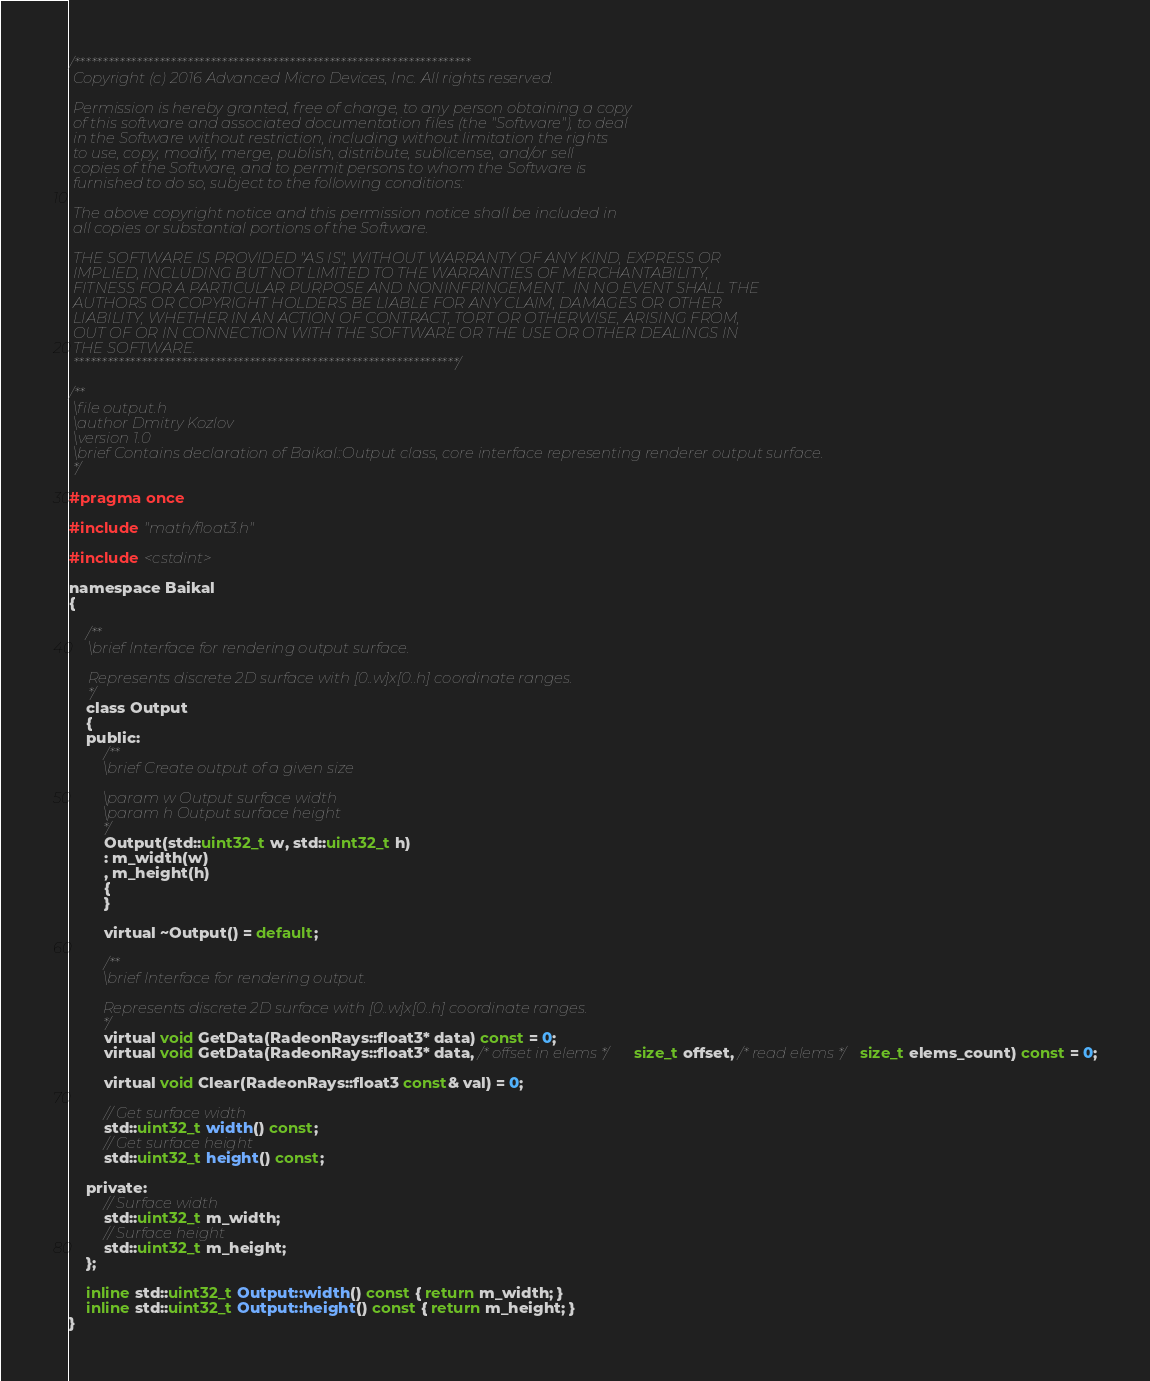<code> <loc_0><loc_0><loc_500><loc_500><_C_>/**********************************************************************
 Copyright (c) 2016 Advanced Micro Devices, Inc. All rights reserved.
 
 Permission is hereby granted, free of charge, to any person obtaining a copy
 of this software and associated documentation files (the "Software"), to deal
 in the Software without restriction, including without limitation the rights
 to use, copy, modify, merge, publish, distribute, sublicense, and/or sell
 copies of the Software, and to permit persons to whom the Software is
 furnished to do so, subject to the following conditions:
 
 The above copyright notice and this permission notice shall be included in
 all copies or substantial portions of the Software.
 
 THE SOFTWARE IS PROVIDED "AS IS", WITHOUT WARRANTY OF ANY KIND, EXPRESS OR
 IMPLIED, INCLUDING BUT NOT LIMITED TO THE WARRANTIES OF MERCHANTABILITY,
 FITNESS FOR A PARTICULAR PURPOSE AND NONINFRINGEMENT.  IN NO EVENT SHALL THE
 AUTHORS OR COPYRIGHT HOLDERS BE LIABLE FOR ANY CLAIM, DAMAGES OR OTHER
 LIABILITY, WHETHER IN AN ACTION OF CONTRACT, TORT OR OTHERWISE, ARISING FROM,
 OUT OF OR IN CONNECTION WITH THE SOFTWARE OR THE USE OR OTHER DEALINGS IN
 THE SOFTWARE.
 ********************************************************************/

/**
 \file output.h
 \author Dmitry Kozlov
 \version 1.0
 \brief Contains declaration of Baikal::Output class, core interface representing renderer output surface.
 */

#pragma once

#include "math/float3.h"

#include <cstdint>

namespace Baikal
{
    
    /**
     \brief Interface for rendering output surface.
     
     Represents discrete 2D surface with [0..w]x[0..h] coordinate ranges.
     */
    class Output
    {
    public:
        /**
         \brief Create output of a given size
         
         \param w Output surface width
         \param h Output surface height
         */
        Output(std::uint32_t w, std::uint32_t h)
        : m_width(w)
        , m_height(h)
        {
        }

        virtual ~Output() = default;

        /**
         \brief Interface for rendering output.
         
         Represents discrete 2D surface with [0..w]x[0..h] coordinate ranges.
         */
        virtual void GetData(RadeonRays::float3* data) const = 0;
        virtual void GetData(RadeonRays::float3* data, /* offset in elems */ size_t offset, /* read elems */size_t elems_count) const = 0;

        virtual void Clear(RadeonRays::float3 const& val) = 0;

        // Get surface width
        std::uint32_t width() const;
        // Get surface height
        std::uint32_t height() const;

    private:
        // Surface width
        std::uint32_t m_width;
        // Surface height
        std::uint32_t m_height;
    };
    
    inline std::uint32_t Output::width() const { return m_width; }
    inline std::uint32_t Output::height() const { return m_height; }
}
</code> 